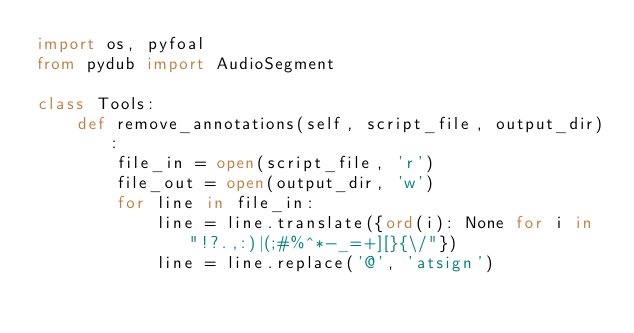Convert code to text. <code><loc_0><loc_0><loc_500><loc_500><_Python_>import os, pyfoal
from pydub import AudioSegment

class Tools:
    def remove_annotations(self, script_file, output_dir):
        file_in = open(script_file, 'r')
        file_out = open(output_dir, 'w')
        for line in file_in:
            line = line.translate({ord(i): None for i in "!?.,:)|(;#%^*-_=+][}{\/"})
            line = line.replace('@', 'atsign')</code> 